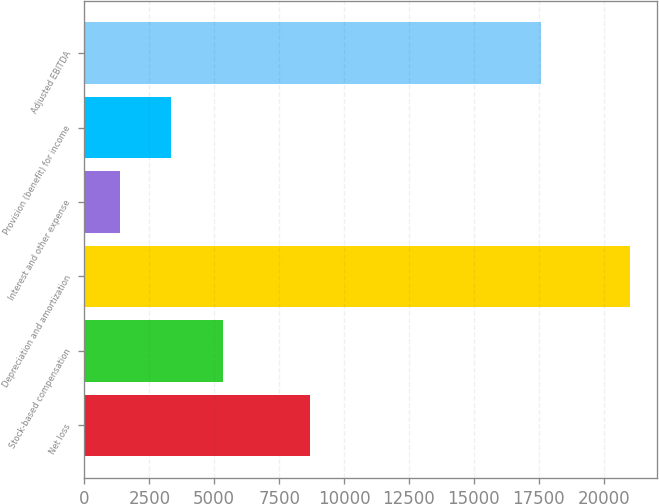<chart> <loc_0><loc_0><loc_500><loc_500><bar_chart><fcel>Net loss<fcel>Stock-based compensation<fcel>Depreciation and amortization<fcel>Interest and other expense<fcel>Provision (benefit) for income<fcel>Adjusted EBITDA<nl><fcel>8705<fcel>5346<fcel>21001<fcel>1357<fcel>3321.4<fcel>17571<nl></chart> 